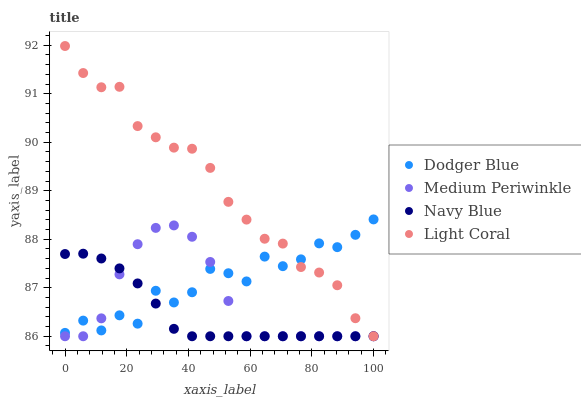Does Navy Blue have the minimum area under the curve?
Answer yes or no. Yes. Does Light Coral have the maximum area under the curve?
Answer yes or no. Yes. Does Medium Periwinkle have the minimum area under the curve?
Answer yes or no. No. Does Medium Periwinkle have the maximum area under the curve?
Answer yes or no. No. Is Navy Blue the smoothest?
Answer yes or no. Yes. Is Dodger Blue the roughest?
Answer yes or no. Yes. Is Medium Periwinkle the smoothest?
Answer yes or no. No. Is Medium Periwinkle the roughest?
Answer yes or no. No. Does Light Coral have the lowest value?
Answer yes or no. Yes. Does Dodger Blue have the lowest value?
Answer yes or no. No. Does Light Coral have the highest value?
Answer yes or no. Yes. Does Medium Periwinkle have the highest value?
Answer yes or no. No. Does Light Coral intersect Dodger Blue?
Answer yes or no. Yes. Is Light Coral less than Dodger Blue?
Answer yes or no. No. Is Light Coral greater than Dodger Blue?
Answer yes or no. No. 